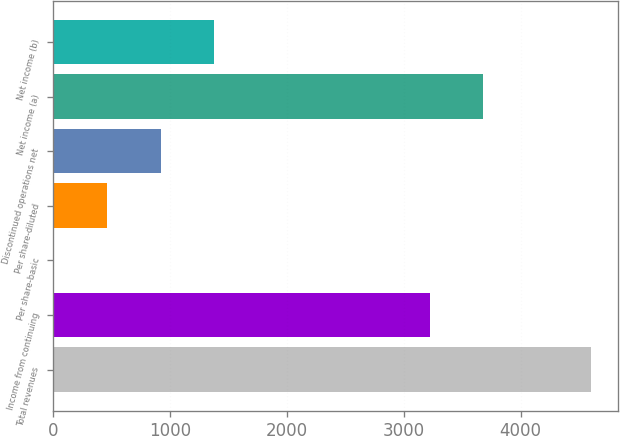Convert chart to OTSL. <chart><loc_0><loc_0><loc_500><loc_500><bar_chart><fcel>Total revenues<fcel>Income from continuing<fcel>Per share-basic<fcel>Per share-diluted<fcel>Discontinued operations net<fcel>Net income (a)<fcel>Net income (b)<nl><fcel>4603<fcel>3222.3<fcel>0.76<fcel>460.98<fcel>921.2<fcel>3682.52<fcel>1381.42<nl></chart> 